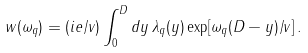<formula> <loc_0><loc_0><loc_500><loc_500>w ( \omega _ { q } ) = ( i e / v ) \int _ { 0 } ^ { D } d y \, \lambda _ { q } ( y ) \exp [ \omega _ { q } ( D - y ) / v ] \, .</formula> 